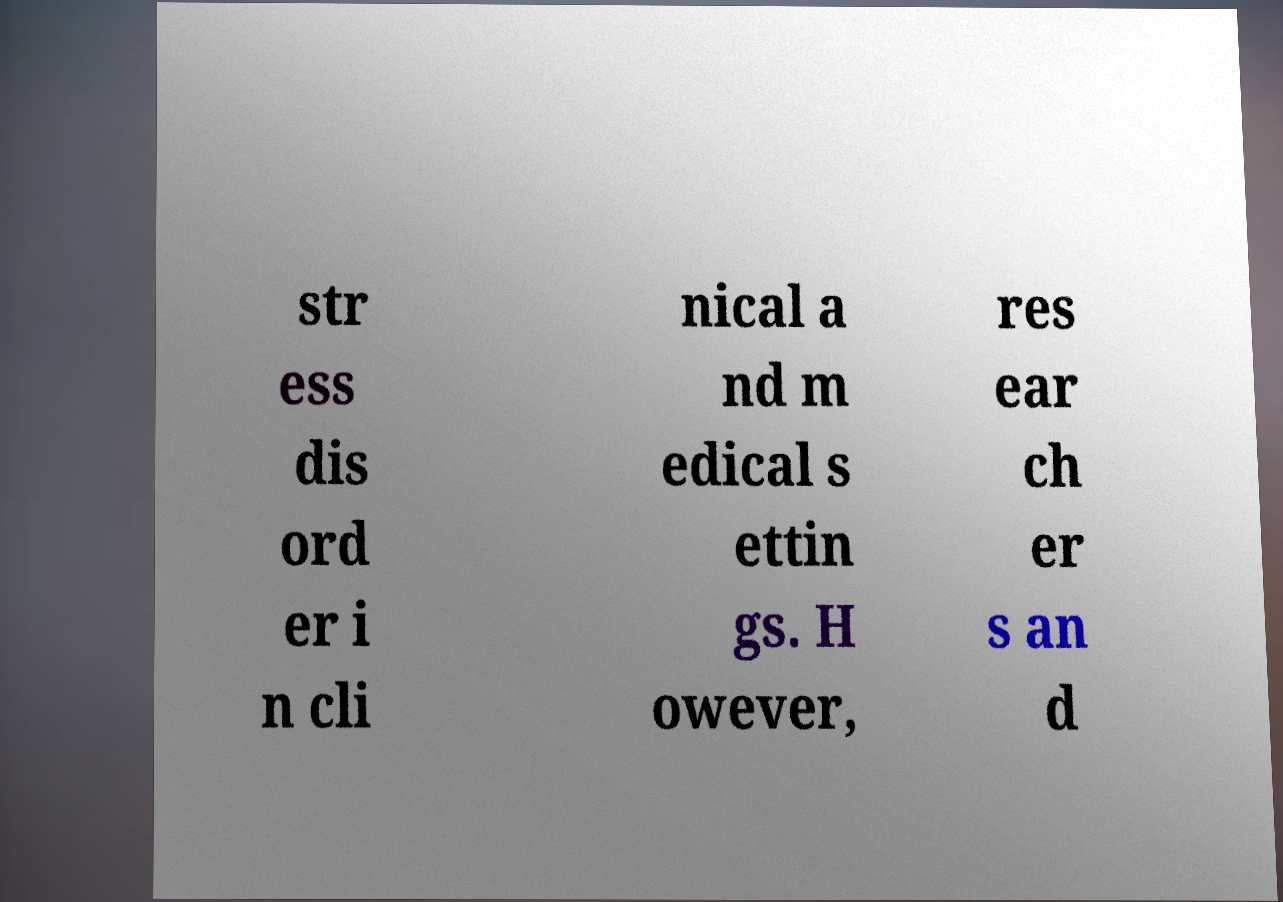For documentation purposes, I need the text within this image transcribed. Could you provide that? str ess dis ord er i n cli nical a nd m edical s ettin gs. H owever, res ear ch er s an d 